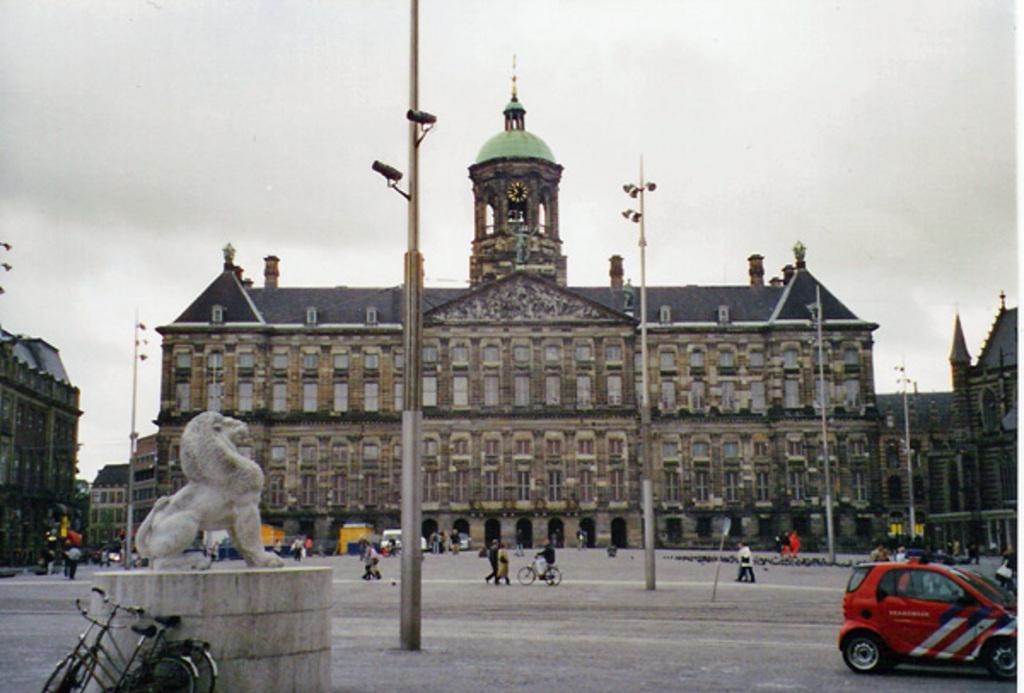What type of surface can be seen in the image? There is ground visible in the image. What objects are present in the image that are used for support or attachment? There are poles in the image. What devices are present in the image for capturing images or videos? There are cameras in the image. What type of sculpture can be seen in the image? There is an animal statue in the image. What type of transportation is present in the image? There are bicycles and a car in the image. Who or what is present in the image that is capable of movement and action? There are people in the image. What type of structures can be seen in the background of the image? There are buildings in the background of the image. What part of the natural environment is visible in the background of the image? The sky is visible in the background of the image. What flavor of question is being asked in the image? There is no question being asked in the image, and therefore no flavor can be determined. How much dust can be seen on the bicycles in the image? There is no mention of dust in the image, and therefore we cannot determine the amount of dust on the bicycles. 